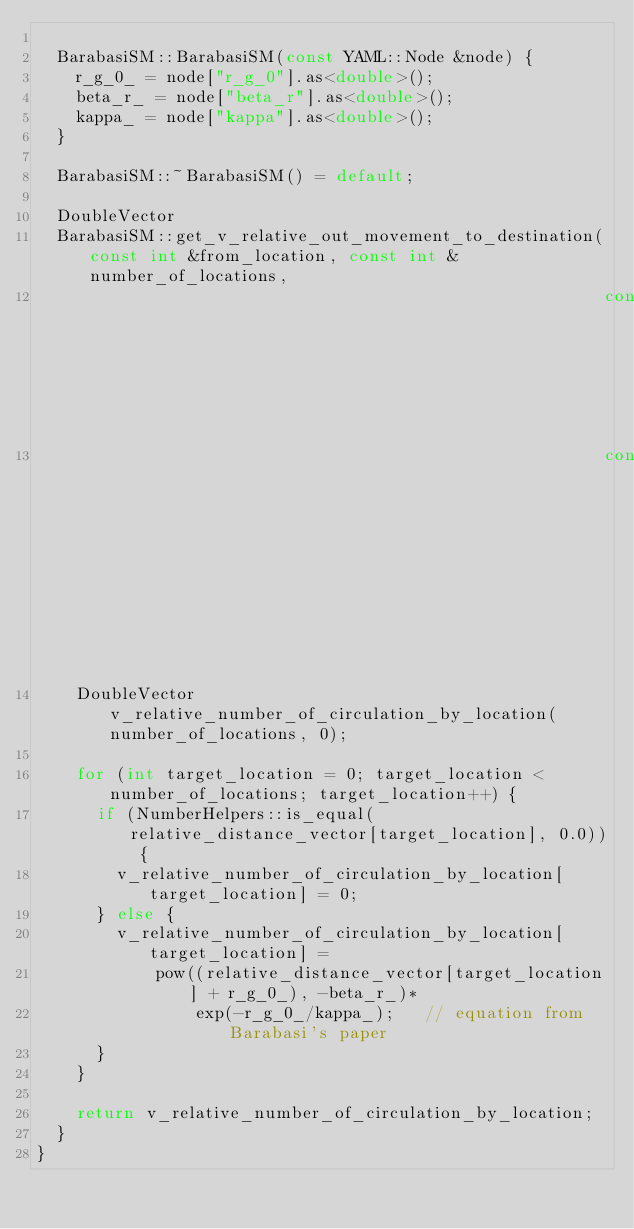Convert code to text. <code><loc_0><loc_0><loc_500><loc_500><_C++_>
  BarabasiSM::BarabasiSM(const YAML::Node &node) {
    r_g_0_ = node["r_g_0"].as<double>();
    beta_r_ = node["beta_r"].as<double>();
    kappa_ = node["kappa"].as<double>();
  }

  BarabasiSM::~BarabasiSM() = default;

  DoubleVector
  BarabasiSM::get_v_relative_out_movement_to_destination(const int &from_location, const int &number_of_locations,
                                                         const DoubleVector &relative_distance_vector,
                                                         const IntVector &v_number_of_residents_by_location) const {
    DoubleVector v_relative_number_of_circulation_by_location(number_of_locations, 0);

    for (int target_location = 0; target_location < number_of_locations; target_location++) {
      if (NumberHelpers::is_equal(relative_distance_vector[target_location], 0.0)) {
        v_relative_number_of_circulation_by_location[target_location] = 0;
      } else {
        v_relative_number_of_circulation_by_location[target_location] =
            pow((relative_distance_vector[target_location] + r_g_0_), -beta_r_)*
                exp(-r_g_0_/kappa_);   // equation from Barabasi's paper
      }
    }

    return v_relative_number_of_circulation_by_location;
  }
}</code> 